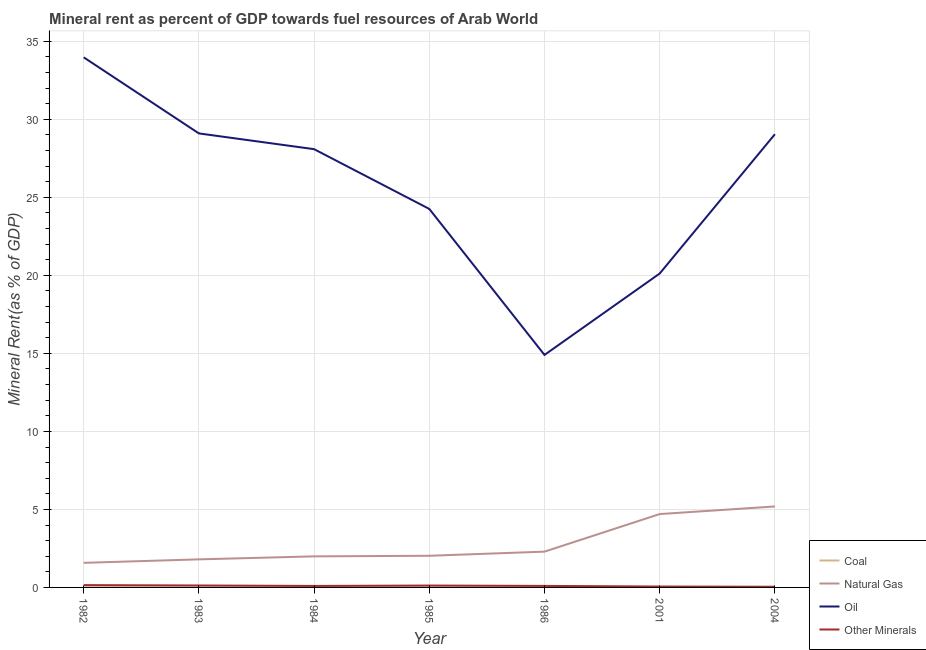How many different coloured lines are there?
Provide a succinct answer. 4. Does the line corresponding to oil rent intersect with the line corresponding to  rent of other minerals?
Provide a short and direct response. No. What is the oil rent in 2004?
Offer a terse response. 29.05. Across all years, what is the maximum  rent of other minerals?
Provide a succinct answer. 0.15. Across all years, what is the minimum natural gas rent?
Provide a short and direct response. 1.58. In which year was the natural gas rent maximum?
Provide a succinct answer. 2004. What is the total  rent of other minerals in the graph?
Provide a short and direct response. 0.69. What is the difference between the coal rent in 1982 and that in 1984?
Offer a very short reply. 0. What is the difference between the  rent of other minerals in 2001 and the natural gas rent in 1983?
Offer a very short reply. -1.74. What is the average oil rent per year?
Provide a succinct answer. 25.64. In the year 2004, what is the difference between the coal rent and oil rent?
Provide a short and direct response. -29.05. What is the ratio of the natural gas rent in 1985 to that in 2001?
Ensure brevity in your answer.  0.43. What is the difference between the highest and the second highest  rent of other minerals?
Your answer should be very brief. 0.02. What is the difference between the highest and the lowest oil rent?
Give a very brief answer. 19.07. Is it the case that in every year, the sum of the coal rent and natural gas rent is greater than the oil rent?
Your response must be concise. No. How many years are there in the graph?
Offer a very short reply. 7. Are the values on the major ticks of Y-axis written in scientific E-notation?
Offer a terse response. No. Does the graph contain any zero values?
Make the answer very short. No. How many legend labels are there?
Keep it short and to the point. 4. What is the title of the graph?
Provide a short and direct response. Mineral rent as percent of GDP towards fuel resources of Arab World. Does "Greece" appear as one of the legend labels in the graph?
Ensure brevity in your answer.  No. What is the label or title of the Y-axis?
Make the answer very short. Mineral Rent(as % of GDP). What is the Mineral Rent(as % of GDP) of Coal in 1982?
Provide a short and direct response. 0. What is the Mineral Rent(as % of GDP) of Natural Gas in 1982?
Your answer should be compact. 1.58. What is the Mineral Rent(as % of GDP) of Oil in 1982?
Make the answer very short. 33.98. What is the Mineral Rent(as % of GDP) of Other Minerals in 1982?
Your answer should be very brief. 0.15. What is the Mineral Rent(as % of GDP) of Coal in 1983?
Offer a terse response. 0. What is the Mineral Rent(as % of GDP) of Natural Gas in 1983?
Offer a very short reply. 1.8. What is the Mineral Rent(as % of GDP) in Oil in 1983?
Your response must be concise. 29.1. What is the Mineral Rent(as % of GDP) of Other Minerals in 1983?
Make the answer very short. 0.12. What is the Mineral Rent(as % of GDP) in Coal in 1984?
Your answer should be compact. 0. What is the Mineral Rent(as % of GDP) of Natural Gas in 1984?
Give a very brief answer. 1.99. What is the Mineral Rent(as % of GDP) in Oil in 1984?
Your answer should be very brief. 28.09. What is the Mineral Rent(as % of GDP) of Other Minerals in 1984?
Give a very brief answer. 0.1. What is the Mineral Rent(as % of GDP) of Coal in 1985?
Ensure brevity in your answer.  0. What is the Mineral Rent(as % of GDP) in Natural Gas in 1985?
Make the answer very short. 2.03. What is the Mineral Rent(as % of GDP) in Oil in 1985?
Provide a succinct answer. 24.26. What is the Mineral Rent(as % of GDP) in Other Minerals in 1985?
Provide a short and direct response. 0.12. What is the Mineral Rent(as % of GDP) of Coal in 1986?
Offer a terse response. 1.4156492772429e-5. What is the Mineral Rent(as % of GDP) in Natural Gas in 1986?
Give a very brief answer. 2.29. What is the Mineral Rent(as % of GDP) in Oil in 1986?
Your response must be concise. 14.9. What is the Mineral Rent(as % of GDP) of Other Minerals in 1986?
Give a very brief answer. 0.1. What is the Mineral Rent(as % of GDP) of Coal in 2001?
Keep it short and to the point. 1.52442917434249e-7. What is the Mineral Rent(as % of GDP) in Natural Gas in 2001?
Your answer should be very brief. 4.7. What is the Mineral Rent(as % of GDP) in Oil in 2001?
Your answer should be compact. 20.12. What is the Mineral Rent(as % of GDP) in Other Minerals in 2001?
Keep it short and to the point. 0.06. What is the Mineral Rent(as % of GDP) of Coal in 2004?
Your answer should be compact. 0. What is the Mineral Rent(as % of GDP) of Natural Gas in 2004?
Your answer should be compact. 5.19. What is the Mineral Rent(as % of GDP) in Oil in 2004?
Offer a very short reply. 29.05. What is the Mineral Rent(as % of GDP) in Other Minerals in 2004?
Keep it short and to the point. 0.04. Across all years, what is the maximum Mineral Rent(as % of GDP) in Coal?
Ensure brevity in your answer.  0. Across all years, what is the maximum Mineral Rent(as % of GDP) of Natural Gas?
Keep it short and to the point. 5.19. Across all years, what is the maximum Mineral Rent(as % of GDP) of Oil?
Your response must be concise. 33.98. Across all years, what is the maximum Mineral Rent(as % of GDP) in Other Minerals?
Keep it short and to the point. 0.15. Across all years, what is the minimum Mineral Rent(as % of GDP) in Coal?
Your answer should be very brief. 1.52442917434249e-7. Across all years, what is the minimum Mineral Rent(as % of GDP) of Natural Gas?
Ensure brevity in your answer.  1.58. Across all years, what is the minimum Mineral Rent(as % of GDP) in Oil?
Your answer should be very brief. 14.9. Across all years, what is the minimum Mineral Rent(as % of GDP) of Other Minerals?
Offer a very short reply. 0.04. What is the total Mineral Rent(as % of GDP) in Coal in the graph?
Offer a very short reply. 0.01. What is the total Mineral Rent(as % of GDP) of Natural Gas in the graph?
Offer a very short reply. 19.58. What is the total Mineral Rent(as % of GDP) of Oil in the graph?
Your answer should be compact. 179.5. What is the total Mineral Rent(as % of GDP) of Other Minerals in the graph?
Keep it short and to the point. 0.69. What is the difference between the Mineral Rent(as % of GDP) in Coal in 1982 and that in 1983?
Ensure brevity in your answer.  0. What is the difference between the Mineral Rent(as % of GDP) in Natural Gas in 1982 and that in 1983?
Provide a short and direct response. -0.22. What is the difference between the Mineral Rent(as % of GDP) in Oil in 1982 and that in 1983?
Offer a terse response. 4.88. What is the difference between the Mineral Rent(as % of GDP) of Other Minerals in 1982 and that in 1983?
Ensure brevity in your answer.  0.02. What is the difference between the Mineral Rent(as % of GDP) of Coal in 1982 and that in 1984?
Provide a succinct answer. 0. What is the difference between the Mineral Rent(as % of GDP) in Natural Gas in 1982 and that in 1984?
Provide a succinct answer. -0.42. What is the difference between the Mineral Rent(as % of GDP) of Oil in 1982 and that in 1984?
Make the answer very short. 5.89. What is the difference between the Mineral Rent(as % of GDP) in Other Minerals in 1982 and that in 1984?
Provide a short and direct response. 0.05. What is the difference between the Mineral Rent(as % of GDP) of Coal in 1982 and that in 1985?
Give a very brief answer. 0. What is the difference between the Mineral Rent(as % of GDP) in Natural Gas in 1982 and that in 1985?
Provide a short and direct response. -0.45. What is the difference between the Mineral Rent(as % of GDP) in Oil in 1982 and that in 1985?
Ensure brevity in your answer.  9.72. What is the difference between the Mineral Rent(as % of GDP) of Other Minerals in 1982 and that in 1985?
Provide a short and direct response. 0.03. What is the difference between the Mineral Rent(as % of GDP) of Coal in 1982 and that in 1986?
Provide a short and direct response. 0. What is the difference between the Mineral Rent(as % of GDP) in Natural Gas in 1982 and that in 1986?
Offer a terse response. -0.72. What is the difference between the Mineral Rent(as % of GDP) of Oil in 1982 and that in 1986?
Provide a succinct answer. 19.07. What is the difference between the Mineral Rent(as % of GDP) of Other Minerals in 1982 and that in 1986?
Your answer should be very brief. 0.05. What is the difference between the Mineral Rent(as % of GDP) of Coal in 1982 and that in 2001?
Keep it short and to the point. 0. What is the difference between the Mineral Rent(as % of GDP) in Natural Gas in 1982 and that in 2001?
Give a very brief answer. -3.13. What is the difference between the Mineral Rent(as % of GDP) in Oil in 1982 and that in 2001?
Keep it short and to the point. 13.86. What is the difference between the Mineral Rent(as % of GDP) in Other Minerals in 1982 and that in 2001?
Provide a succinct answer. 0.09. What is the difference between the Mineral Rent(as % of GDP) in Coal in 1982 and that in 2004?
Make the answer very short. 0. What is the difference between the Mineral Rent(as % of GDP) in Natural Gas in 1982 and that in 2004?
Provide a short and direct response. -3.61. What is the difference between the Mineral Rent(as % of GDP) of Oil in 1982 and that in 2004?
Provide a succinct answer. 4.93. What is the difference between the Mineral Rent(as % of GDP) of Other Minerals in 1982 and that in 2004?
Provide a short and direct response. 0.1. What is the difference between the Mineral Rent(as % of GDP) of Coal in 1983 and that in 1984?
Your answer should be compact. 0. What is the difference between the Mineral Rent(as % of GDP) in Natural Gas in 1983 and that in 1984?
Ensure brevity in your answer.  -0.19. What is the difference between the Mineral Rent(as % of GDP) in Oil in 1983 and that in 1984?
Your answer should be compact. 1.01. What is the difference between the Mineral Rent(as % of GDP) of Other Minerals in 1983 and that in 1984?
Provide a short and direct response. 0.03. What is the difference between the Mineral Rent(as % of GDP) of Natural Gas in 1983 and that in 1985?
Your answer should be very brief. -0.23. What is the difference between the Mineral Rent(as % of GDP) in Oil in 1983 and that in 1985?
Offer a terse response. 4.84. What is the difference between the Mineral Rent(as % of GDP) in Other Minerals in 1983 and that in 1985?
Your answer should be very brief. 0. What is the difference between the Mineral Rent(as % of GDP) in Coal in 1983 and that in 1986?
Make the answer very short. 0. What is the difference between the Mineral Rent(as % of GDP) of Natural Gas in 1983 and that in 1986?
Your answer should be compact. -0.49. What is the difference between the Mineral Rent(as % of GDP) of Oil in 1983 and that in 1986?
Provide a succinct answer. 14.2. What is the difference between the Mineral Rent(as % of GDP) of Other Minerals in 1983 and that in 1986?
Offer a very short reply. 0.03. What is the difference between the Mineral Rent(as % of GDP) of Coal in 1983 and that in 2001?
Provide a succinct answer. 0. What is the difference between the Mineral Rent(as % of GDP) in Natural Gas in 1983 and that in 2001?
Make the answer very short. -2.9. What is the difference between the Mineral Rent(as % of GDP) of Oil in 1983 and that in 2001?
Keep it short and to the point. 8.98. What is the difference between the Mineral Rent(as % of GDP) in Other Minerals in 1983 and that in 2001?
Give a very brief answer. 0.07. What is the difference between the Mineral Rent(as % of GDP) of Coal in 1983 and that in 2004?
Offer a very short reply. 0. What is the difference between the Mineral Rent(as % of GDP) of Natural Gas in 1983 and that in 2004?
Offer a very short reply. -3.39. What is the difference between the Mineral Rent(as % of GDP) in Oil in 1983 and that in 2004?
Offer a very short reply. 0.05. What is the difference between the Mineral Rent(as % of GDP) in Other Minerals in 1983 and that in 2004?
Give a very brief answer. 0.08. What is the difference between the Mineral Rent(as % of GDP) of Coal in 1984 and that in 1985?
Your response must be concise. -0. What is the difference between the Mineral Rent(as % of GDP) of Natural Gas in 1984 and that in 1985?
Offer a terse response. -0.04. What is the difference between the Mineral Rent(as % of GDP) in Oil in 1984 and that in 1985?
Your answer should be very brief. 3.83. What is the difference between the Mineral Rent(as % of GDP) of Other Minerals in 1984 and that in 1985?
Offer a terse response. -0.03. What is the difference between the Mineral Rent(as % of GDP) of Coal in 1984 and that in 1986?
Provide a succinct answer. 0. What is the difference between the Mineral Rent(as % of GDP) in Natural Gas in 1984 and that in 1986?
Offer a very short reply. -0.3. What is the difference between the Mineral Rent(as % of GDP) of Oil in 1984 and that in 1986?
Ensure brevity in your answer.  13.19. What is the difference between the Mineral Rent(as % of GDP) of Other Minerals in 1984 and that in 1986?
Offer a very short reply. -0. What is the difference between the Mineral Rent(as % of GDP) of Coal in 1984 and that in 2001?
Make the answer very short. 0. What is the difference between the Mineral Rent(as % of GDP) of Natural Gas in 1984 and that in 2001?
Ensure brevity in your answer.  -2.71. What is the difference between the Mineral Rent(as % of GDP) of Oil in 1984 and that in 2001?
Offer a very short reply. 7.97. What is the difference between the Mineral Rent(as % of GDP) in Other Minerals in 1984 and that in 2001?
Your answer should be compact. 0.04. What is the difference between the Mineral Rent(as % of GDP) in Coal in 1984 and that in 2004?
Provide a succinct answer. 0. What is the difference between the Mineral Rent(as % of GDP) in Natural Gas in 1984 and that in 2004?
Your response must be concise. -3.2. What is the difference between the Mineral Rent(as % of GDP) of Oil in 1984 and that in 2004?
Provide a short and direct response. -0.96. What is the difference between the Mineral Rent(as % of GDP) in Other Minerals in 1984 and that in 2004?
Ensure brevity in your answer.  0.05. What is the difference between the Mineral Rent(as % of GDP) of Coal in 1985 and that in 1986?
Your response must be concise. 0. What is the difference between the Mineral Rent(as % of GDP) in Natural Gas in 1985 and that in 1986?
Your answer should be very brief. -0.26. What is the difference between the Mineral Rent(as % of GDP) in Oil in 1985 and that in 1986?
Offer a terse response. 9.36. What is the difference between the Mineral Rent(as % of GDP) in Other Minerals in 1985 and that in 1986?
Give a very brief answer. 0.02. What is the difference between the Mineral Rent(as % of GDP) in Coal in 1985 and that in 2001?
Make the answer very short. 0. What is the difference between the Mineral Rent(as % of GDP) of Natural Gas in 1985 and that in 2001?
Your answer should be compact. -2.67. What is the difference between the Mineral Rent(as % of GDP) in Oil in 1985 and that in 2001?
Provide a short and direct response. 4.14. What is the difference between the Mineral Rent(as % of GDP) of Other Minerals in 1985 and that in 2001?
Your answer should be very brief. 0.06. What is the difference between the Mineral Rent(as % of GDP) of Coal in 1985 and that in 2004?
Give a very brief answer. 0. What is the difference between the Mineral Rent(as % of GDP) of Natural Gas in 1985 and that in 2004?
Give a very brief answer. -3.16. What is the difference between the Mineral Rent(as % of GDP) in Oil in 1985 and that in 2004?
Offer a terse response. -4.79. What is the difference between the Mineral Rent(as % of GDP) of Other Minerals in 1985 and that in 2004?
Provide a succinct answer. 0.08. What is the difference between the Mineral Rent(as % of GDP) of Coal in 1986 and that in 2001?
Ensure brevity in your answer.  0. What is the difference between the Mineral Rent(as % of GDP) in Natural Gas in 1986 and that in 2001?
Your response must be concise. -2.41. What is the difference between the Mineral Rent(as % of GDP) of Oil in 1986 and that in 2001?
Offer a very short reply. -5.22. What is the difference between the Mineral Rent(as % of GDP) of Other Minerals in 1986 and that in 2001?
Your answer should be very brief. 0.04. What is the difference between the Mineral Rent(as % of GDP) of Coal in 1986 and that in 2004?
Provide a short and direct response. -0. What is the difference between the Mineral Rent(as % of GDP) of Natural Gas in 1986 and that in 2004?
Offer a terse response. -2.9. What is the difference between the Mineral Rent(as % of GDP) in Oil in 1986 and that in 2004?
Your answer should be compact. -14.15. What is the difference between the Mineral Rent(as % of GDP) in Other Minerals in 1986 and that in 2004?
Your response must be concise. 0.05. What is the difference between the Mineral Rent(as % of GDP) of Coal in 2001 and that in 2004?
Ensure brevity in your answer.  -0. What is the difference between the Mineral Rent(as % of GDP) of Natural Gas in 2001 and that in 2004?
Make the answer very short. -0.49. What is the difference between the Mineral Rent(as % of GDP) of Oil in 2001 and that in 2004?
Provide a short and direct response. -8.93. What is the difference between the Mineral Rent(as % of GDP) in Other Minerals in 2001 and that in 2004?
Provide a short and direct response. 0.01. What is the difference between the Mineral Rent(as % of GDP) in Coal in 1982 and the Mineral Rent(as % of GDP) in Natural Gas in 1983?
Your answer should be compact. -1.8. What is the difference between the Mineral Rent(as % of GDP) of Coal in 1982 and the Mineral Rent(as % of GDP) of Oil in 1983?
Make the answer very short. -29.1. What is the difference between the Mineral Rent(as % of GDP) in Coal in 1982 and the Mineral Rent(as % of GDP) in Other Minerals in 1983?
Make the answer very short. -0.12. What is the difference between the Mineral Rent(as % of GDP) of Natural Gas in 1982 and the Mineral Rent(as % of GDP) of Oil in 1983?
Give a very brief answer. -27.52. What is the difference between the Mineral Rent(as % of GDP) in Natural Gas in 1982 and the Mineral Rent(as % of GDP) in Other Minerals in 1983?
Provide a short and direct response. 1.45. What is the difference between the Mineral Rent(as % of GDP) in Oil in 1982 and the Mineral Rent(as % of GDP) in Other Minerals in 1983?
Provide a short and direct response. 33.85. What is the difference between the Mineral Rent(as % of GDP) of Coal in 1982 and the Mineral Rent(as % of GDP) of Natural Gas in 1984?
Your response must be concise. -1.99. What is the difference between the Mineral Rent(as % of GDP) of Coal in 1982 and the Mineral Rent(as % of GDP) of Oil in 1984?
Your answer should be compact. -28.09. What is the difference between the Mineral Rent(as % of GDP) in Coal in 1982 and the Mineral Rent(as % of GDP) in Other Minerals in 1984?
Make the answer very short. -0.09. What is the difference between the Mineral Rent(as % of GDP) in Natural Gas in 1982 and the Mineral Rent(as % of GDP) in Oil in 1984?
Make the answer very short. -26.51. What is the difference between the Mineral Rent(as % of GDP) in Natural Gas in 1982 and the Mineral Rent(as % of GDP) in Other Minerals in 1984?
Offer a terse response. 1.48. What is the difference between the Mineral Rent(as % of GDP) in Oil in 1982 and the Mineral Rent(as % of GDP) in Other Minerals in 1984?
Make the answer very short. 33.88. What is the difference between the Mineral Rent(as % of GDP) in Coal in 1982 and the Mineral Rent(as % of GDP) in Natural Gas in 1985?
Provide a succinct answer. -2.03. What is the difference between the Mineral Rent(as % of GDP) in Coal in 1982 and the Mineral Rent(as % of GDP) in Oil in 1985?
Your response must be concise. -24.26. What is the difference between the Mineral Rent(as % of GDP) in Coal in 1982 and the Mineral Rent(as % of GDP) in Other Minerals in 1985?
Keep it short and to the point. -0.12. What is the difference between the Mineral Rent(as % of GDP) of Natural Gas in 1982 and the Mineral Rent(as % of GDP) of Oil in 1985?
Keep it short and to the point. -22.68. What is the difference between the Mineral Rent(as % of GDP) of Natural Gas in 1982 and the Mineral Rent(as % of GDP) of Other Minerals in 1985?
Give a very brief answer. 1.45. What is the difference between the Mineral Rent(as % of GDP) in Oil in 1982 and the Mineral Rent(as % of GDP) in Other Minerals in 1985?
Give a very brief answer. 33.86. What is the difference between the Mineral Rent(as % of GDP) in Coal in 1982 and the Mineral Rent(as % of GDP) in Natural Gas in 1986?
Ensure brevity in your answer.  -2.29. What is the difference between the Mineral Rent(as % of GDP) in Coal in 1982 and the Mineral Rent(as % of GDP) in Oil in 1986?
Ensure brevity in your answer.  -14.9. What is the difference between the Mineral Rent(as % of GDP) of Coal in 1982 and the Mineral Rent(as % of GDP) of Other Minerals in 1986?
Give a very brief answer. -0.09. What is the difference between the Mineral Rent(as % of GDP) of Natural Gas in 1982 and the Mineral Rent(as % of GDP) of Oil in 1986?
Offer a terse response. -13.33. What is the difference between the Mineral Rent(as % of GDP) in Natural Gas in 1982 and the Mineral Rent(as % of GDP) in Other Minerals in 1986?
Give a very brief answer. 1.48. What is the difference between the Mineral Rent(as % of GDP) in Oil in 1982 and the Mineral Rent(as % of GDP) in Other Minerals in 1986?
Your answer should be compact. 33.88. What is the difference between the Mineral Rent(as % of GDP) of Coal in 1982 and the Mineral Rent(as % of GDP) of Natural Gas in 2001?
Provide a short and direct response. -4.7. What is the difference between the Mineral Rent(as % of GDP) in Coal in 1982 and the Mineral Rent(as % of GDP) in Oil in 2001?
Keep it short and to the point. -20.12. What is the difference between the Mineral Rent(as % of GDP) in Coal in 1982 and the Mineral Rent(as % of GDP) in Other Minerals in 2001?
Provide a succinct answer. -0.05. What is the difference between the Mineral Rent(as % of GDP) of Natural Gas in 1982 and the Mineral Rent(as % of GDP) of Oil in 2001?
Give a very brief answer. -18.54. What is the difference between the Mineral Rent(as % of GDP) in Natural Gas in 1982 and the Mineral Rent(as % of GDP) in Other Minerals in 2001?
Offer a very short reply. 1.52. What is the difference between the Mineral Rent(as % of GDP) of Oil in 1982 and the Mineral Rent(as % of GDP) of Other Minerals in 2001?
Your answer should be very brief. 33.92. What is the difference between the Mineral Rent(as % of GDP) of Coal in 1982 and the Mineral Rent(as % of GDP) of Natural Gas in 2004?
Your response must be concise. -5.19. What is the difference between the Mineral Rent(as % of GDP) in Coal in 1982 and the Mineral Rent(as % of GDP) in Oil in 2004?
Provide a succinct answer. -29.04. What is the difference between the Mineral Rent(as % of GDP) of Coal in 1982 and the Mineral Rent(as % of GDP) of Other Minerals in 2004?
Keep it short and to the point. -0.04. What is the difference between the Mineral Rent(as % of GDP) of Natural Gas in 1982 and the Mineral Rent(as % of GDP) of Oil in 2004?
Your answer should be compact. -27.47. What is the difference between the Mineral Rent(as % of GDP) in Natural Gas in 1982 and the Mineral Rent(as % of GDP) in Other Minerals in 2004?
Offer a terse response. 1.53. What is the difference between the Mineral Rent(as % of GDP) in Oil in 1982 and the Mineral Rent(as % of GDP) in Other Minerals in 2004?
Your response must be concise. 33.93. What is the difference between the Mineral Rent(as % of GDP) of Coal in 1983 and the Mineral Rent(as % of GDP) of Natural Gas in 1984?
Provide a short and direct response. -1.99. What is the difference between the Mineral Rent(as % of GDP) of Coal in 1983 and the Mineral Rent(as % of GDP) of Oil in 1984?
Offer a very short reply. -28.09. What is the difference between the Mineral Rent(as % of GDP) in Coal in 1983 and the Mineral Rent(as % of GDP) in Other Minerals in 1984?
Give a very brief answer. -0.09. What is the difference between the Mineral Rent(as % of GDP) of Natural Gas in 1983 and the Mineral Rent(as % of GDP) of Oil in 1984?
Offer a very short reply. -26.29. What is the difference between the Mineral Rent(as % of GDP) of Natural Gas in 1983 and the Mineral Rent(as % of GDP) of Other Minerals in 1984?
Your response must be concise. 1.7. What is the difference between the Mineral Rent(as % of GDP) in Oil in 1983 and the Mineral Rent(as % of GDP) in Other Minerals in 1984?
Offer a terse response. 29. What is the difference between the Mineral Rent(as % of GDP) of Coal in 1983 and the Mineral Rent(as % of GDP) of Natural Gas in 1985?
Your answer should be compact. -2.03. What is the difference between the Mineral Rent(as % of GDP) in Coal in 1983 and the Mineral Rent(as % of GDP) in Oil in 1985?
Keep it short and to the point. -24.26. What is the difference between the Mineral Rent(as % of GDP) in Coal in 1983 and the Mineral Rent(as % of GDP) in Other Minerals in 1985?
Your answer should be compact. -0.12. What is the difference between the Mineral Rent(as % of GDP) of Natural Gas in 1983 and the Mineral Rent(as % of GDP) of Oil in 1985?
Your response must be concise. -22.46. What is the difference between the Mineral Rent(as % of GDP) of Natural Gas in 1983 and the Mineral Rent(as % of GDP) of Other Minerals in 1985?
Ensure brevity in your answer.  1.68. What is the difference between the Mineral Rent(as % of GDP) of Oil in 1983 and the Mineral Rent(as % of GDP) of Other Minerals in 1985?
Your response must be concise. 28.98. What is the difference between the Mineral Rent(as % of GDP) of Coal in 1983 and the Mineral Rent(as % of GDP) of Natural Gas in 1986?
Offer a terse response. -2.29. What is the difference between the Mineral Rent(as % of GDP) of Coal in 1983 and the Mineral Rent(as % of GDP) of Oil in 1986?
Your answer should be very brief. -14.9. What is the difference between the Mineral Rent(as % of GDP) of Coal in 1983 and the Mineral Rent(as % of GDP) of Other Minerals in 1986?
Make the answer very short. -0.1. What is the difference between the Mineral Rent(as % of GDP) of Natural Gas in 1983 and the Mineral Rent(as % of GDP) of Oil in 1986?
Offer a very short reply. -13.1. What is the difference between the Mineral Rent(as % of GDP) in Natural Gas in 1983 and the Mineral Rent(as % of GDP) in Other Minerals in 1986?
Keep it short and to the point. 1.7. What is the difference between the Mineral Rent(as % of GDP) of Oil in 1983 and the Mineral Rent(as % of GDP) of Other Minerals in 1986?
Your answer should be very brief. 29. What is the difference between the Mineral Rent(as % of GDP) of Coal in 1983 and the Mineral Rent(as % of GDP) of Natural Gas in 2001?
Your answer should be compact. -4.7. What is the difference between the Mineral Rent(as % of GDP) in Coal in 1983 and the Mineral Rent(as % of GDP) in Oil in 2001?
Provide a short and direct response. -20.12. What is the difference between the Mineral Rent(as % of GDP) in Coal in 1983 and the Mineral Rent(as % of GDP) in Other Minerals in 2001?
Offer a terse response. -0.06. What is the difference between the Mineral Rent(as % of GDP) of Natural Gas in 1983 and the Mineral Rent(as % of GDP) of Oil in 2001?
Give a very brief answer. -18.32. What is the difference between the Mineral Rent(as % of GDP) of Natural Gas in 1983 and the Mineral Rent(as % of GDP) of Other Minerals in 2001?
Offer a terse response. 1.74. What is the difference between the Mineral Rent(as % of GDP) of Oil in 1983 and the Mineral Rent(as % of GDP) of Other Minerals in 2001?
Your answer should be very brief. 29.04. What is the difference between the Mineral Rent(as % of GDP) of Coal in 1983 and the Mineral Rent(as % of GDP) of Natural Gas in 2004?
Give a very brief answer. -5.19. What is the difference between the Mineral Rent(as % of GDP) of Coal in 1983 and the Mineral Rent(as % of GDP) of Oil in 2004?
Ensure brevity in your answer.  -29.05. What is the difference between the Mineral Rent(as % of GDP) of Coal in 1983 and the Mineral Rent(as % of GDP) of Other Minerals in 2004?
Offer a very short reply. -0.04. What is the difference between the Mineral Rent(as % of GDP) of Natural Gas in 1983 and the Mineral Rent(as % of GDP) of Oil in 2004?
Offer a terse response. -27.25. What is the difference between the Mineral Rent(as % of GDP) of Natural Gas in 1983 and the Mineral Rent(as % of GDP) of Other Minerals in 2004?
Provide a short and direct response. 1.76. What is the difference between the Mineral Rent(as % of GDP) of Oil in 1983 and the Mineral Rent(as % of GDP) of Other Minerals in 2004?
Make the answer very short. 29.06. What is the difference between the Mineral Rent(as % of GDP) in Coal in 1984 and the Mineral Rent(as % of GDP) in Natural Gas in 1985?
Keep it short and to the point. -2.03. What is the difference between the Mineral Rent(as % of GDP) of Coal in 1984 and the Mineral Rent(as % of GDP) of Oil in 1985?
Offer a terse response. -24.26. What is the difference between the Mineral Rent(as % of GDP) of Coal in 1984 and the Mineral Rent(as % of GDP) of Other Minerals in 1985?
Your answer should be compact. -0.12. What is the difference between the Mineral Rent(as % of GDP) in Natural Gas in 1984 and the Mineral Rent(as % of GDP) in Oil in 1985?
Provide a succinct answer. -22.27. What is the difference between the Mineral Rent(as % of GDP) in Natural Gas in 1984 and the Mineral Rent(as % of GDP) in Other Minerals in 1985?
Keep it short and to the point. 1.87. What is the difference between the Mineral Rent(as % of GDP) of Oil in 1984 and the Mineral Rent(as % of GDP) of Other Minerals in 1985?
Your answer should be compact. 27.97. What is the difference between the Mineral Rent(as % of GDP) of Coal in 1984 and the Mineral Rent(as % of GDP) of Natural Gas in 1986?
Provide a succinct answer. -2.29. What is the difference between the Mineral Rent(as % of GDP) of Coal in 1984 and the Mineral Rent(as % of GDP) of Oil in 1986?
Ensure brevity in your answer.  -14.9. What is the difference between the Mineral Rent(as % of GDP) of Coal in 1984 and the Mineral Rent(as % of GDP) of Other Minerals in 1986?
Keep it short and to the point. -0.1. What is the difference between the Mineral Rent(as % of GDP) in Natural Gas in 1984 and the Mineral Rent(as % of GDP) in Oil in 1986?
Your response must be concise. -12.91. What is the difference between the Mineral Rent(as % of GDP) in Natural Gas in 1984 and the Mineral Rent(as % of GDP) in Other Minerals in 1986?
Your answer should be very brief. 1.89. What is the difference between the Mineral Rent(as % of GDP) in Oil in 1984 and the Mineral Rent(as % of GDP) in Other Minerals in 1986?
Your response must be concise. 27.99. What is the difference between the Mineral Rent(as % of GDP) of Coal in 1984 and the Mineral Rent(as % of GDP) of Natural Gas in 2001?
Provide a succinct answer. -4.7. What is the difference between the Mineral Rent(as % of GDP) in Coal in 1984 and the Mineral Rent(as % of GDP) in Oil in 2001?
Your answer should be very brief. -20.12. What is the difference between the Mineral Rent(as % of GDP) in Coal in 1984 and the Mineral Rent(as % of GDP) in Other Minerals in 2001?
Offer a terse response. -0.06. What is the difference between the Mineral Rent(as % of GDP) of Natural Gas in 1984 and the Mineral Rent(as % of GDP) of Oil in 2001?
Offer a very short reply. -18.13. What is the difference between the Mineral Rent(as % of GDP) in Natural Gas in 1984 and the Mineral Rent(as % of GDP) in Other Minerals in 2001?
Give a very brief answer. 1.93. What is the difference between the Mineral Rent(as % of GDP) in Oil in 1984 and the Mineral Rent(as % of GDP) in Other Minerals in 2001?
Offer a very short reply. 28.03. What is the difference between the Mineral Rent(as % of GDP) in Coal in 1984 and the Mineral Rent(as % of GDP) in Natural Gas in 2004?
Your answer should be compact. -5.19. What is the difference between the Mineral Rent(as % of GDP) in Coal in 1984 and the Mineral Rent(as % of GDP) in Oil in 2004?
Keep it short and to the point. -29.05. What is the difference between the Mineral Rent(as % of GDP) of Coal in 1984 and the Mineral Rent(as % of GDP) of Other Minerals in 2004?
Offer a terse response. -0.04. What is the difference between the Mineral Rent(as % of GDP) of Natural Gas in 1984 and the Mineral Rent(as % of GDP) of Oil in 2004?
Give a very brief answer. -27.06. What is the difference between the Mineral Rent(as % of GDP) of Natural Gas in 1984 and the Mineral Rent(as % of GDP) of Other Minerals in 2004?
Make the answer very short. 1.95. What is the difference between the Mineral Rent(as % of GDP) of Oil in 1984 and the Mineral Rent(as % of GDP) of Other Minerals in 2004?
Ensure brevity in your answer.  28.05. What is the difference between the Mineral Rent(as % of GDP) in Coal in 1985 and the Mineral Rent(as % of GDP) in Natural Gas in 1986?
Keep it short and to the point. -2.29. What is the difference between the Mineral Rent(as % of GDP) in Coal in 1985 and the Mineral Rent(as % of GDP) in Oil in 1986?
Offer a very short reply. -14.9. What is the difference between the Mineral Rent(as % of GDP) in Coal in 1985 and the Mineral Rent(as % of GDP) in Other Minerals in 1986?
Your response must be concise. -0.1. What is the difference between the Mineral Rent(as % of GDP) in Natural Gas in 1985 and the Mineral Rent(as % of GDP) in Oil in 1986?
Your answer should be compact. -12.87. What is the difference between the Mineral Rent(as % of GDP) of Natural Gas in 1985 and the Mineral Rent(as % of GDP) of Other Minerals in 1986?
Ensure brevity in your answer.  1.93. What is the difference between the Mineral Rent(as % of GDP) of Oil in 1985 and the Mineral Rent(as % of GDP) of Other Minerals in 1986?
Your answer should be compact. 24.16. What is the difference between the Mineral Rent(as % of GDP) of Coal in 1985 and the Mineral Rent(as % of GDP) of Natural Gas in 2001?
Offer a terse response. -4.7. What is the difference between the Mineral Rent(as % of GDP) of Coal in 1985 and the Mineral Rent(as % of GDP) of Oil in 2001?
Your answer should be compact. -20.12. What is the difference between the Mineral Rent(as % of GDP) in Coal in 1985 and the Mineral Rent(as % of GDP) in Other Minerals in 2001?
Your answer should be very brief. -0.06. What is the difference between the Mineral Rent(as % of GDP) of Natural Gas in 1985 and the Mineral Rent(as % of GDP) of Oil in 2001?
Your answer should be very brief. -18.09. What is the difference between the Mineral Rent(as % of GDP) of Natural Gas in 1985 and the Mineral Rent(as % of GDP) of Other Minerals in 2001?
Ensure brevity in your answer.  1.97. What is the difference between the Mineral Rent(as % of GDP) of Oil in 1985 and the Mineral Rent(as % of GDP) of Other Minerals in 2001?
Keep it short and to the point. 24.2. What is the difference between the Mineral Rent(as % of GDP) of Coal in 1985 and the Mineral Rent(as % of GDP) of Natural Gas in 2004?
Provide a short and direct response. -5.19. What is the difference between the Mineral Rent(as % of GDP) in Coal in 1985 and the Mineral Rent(as % of GDP) in Oil in 2004?
Ensure brevity in your answer.  -29.05. What is the difference between the Mineral Rent(as % of GDP) in Coal in 1985 and the Mineral Rent(as % of GDP) in Other Minerals in 2004?
Ensure brevity in your answer.  -0.04. What is the difference between the Mineral Rent(as % of GDP) in Natural Gas in 1985 and the Mineral Rent(as % of GDP) in Oil in 2004?
Your answer should be compact. -27.02. What is the difference between the Mineral Rent(as % of GDP) of Natural Gas in 1985 and the Mineral Rent(as % of GDP) of Other Minerals in 2004?
Your answer should be compact. 1.99. What is the difference between the Mineral Rent(as % of GDP) in Oil in 1985 and the Mineral Rent(as % of GDP) in Other Minerals in 2004?
Your response must be concise. 24.22. What is the difference between the Mineral Rent(as % of GDP) in Coal in 1986 and the Mineral Rent(as % of GDP) in Natural Gas in 2001?
Your response must be concise. -4.7. What is the difference between the Mineral Rent(as % of GDP) of Coal in 1986 and the Mineral Rent(as % of GDP) of Oil in 2001?
Provide a succinct answer. -20.12. What is the difference between the Mineral Rent(as % of GDP) of Coal in 1986 and the Mineral Rent(as % of GDP) of Other Minerals in 2001?
Your response must be concise. -0.06. What is the difference between the Mineral Rent(as % of GDP) in Natural Gas in 1986 and the Mineral Rent(as % of GDP) in Oil in 2001?
Offer a terse response. -17.83. What is the difference between the Mineral Rent(as % of GDP) in Natural Gas in 1986 and the Mineral Rent(as % of GDP) in Other Minerals in 2001?
Your answer should be very brief. 2.24. What is the difference between the Mineral Rent(as % of GDP) in Oil in 1986 and the Mineral Rent(as % of GDP) in Other Minerals in 2001?
Your answer should be compact. 14.85. What is the difference between the Mineral Rent(as % of GDP) of Coal in 1986 and the Mineral Rent(as % of GDP) of Natural Gas in 2004?
Provide a short and direct response. -5.19. What is the difference between the Mineral Rent(as % of GDP) in Coal in 1986 and the Mineral Rent(as % of GDP) in Oil in 2004?
Offer a very short reply. -29.05. What is the difference between the Mineral Rent(as % of GDP) of Coal in 1986 and the Mineral Rent(as % of GDP) of Other Minerals in 2004?
Give a very brief answer. -0.04. What is the difference between the Mineral Rent(as % of GDP) in Natural Gas in 1986 and the Mineral Rent(as % of GDP) in Oil in 2004?
Keep it short and to the point. -26.75. What is the difference between the Mineral Rent(as % of GDP) in Natural Gas in 1986 and the Mineral Rent(as % of GDP) in Other Minerals in 2004?
Provide a succinct answer. 2.25. What is the difference between the Mineral Rent(as % of GDP) in Oil in 1986 and the Mineral Rent(as % of GDP) in Other Minerals in 2004?
Make the answer very short. 14.86. What is the difference between the Mineral Rent(as % of GDP) of Coal in 2001 and the Mineral Rent(as % of GDP) of Natural Gas in 2004?
Your answer should be very brief. -5.19. What is the difference between the Mineral Rent(as % of GDP) in Coal in 2001 and the Mineral Rent(as % of GDP) in Oil in 2004?
Give a very brief answer. -29.05. What is the difference between the Mineral Rent(as % of GDP) of Coal in 2001 and the Mineral Rent(as % of GDP) of Other Minerals in 2004?
Your answer should be compact. -0.04. What is the difference between the Mineral Rent(as % of GDP) of Natural Gas in 2001 and the Mineral Rent(as % of GDP) of Oil in 2004?
Your response must be concise. -24.35. What is the difference between the Mineral Rent(as % of GDP) in Natural Gas in 2001 and the Mineral Rent(as % of GDP) in Other Minerals in 2004?
Your answer should be very brief. 4.66. What is the difference between the Mineral Rent(as % of GDP) in Oil in 2001 and the Mineral Rent(as % of GDP) in Other Minerals in 2004?
Make the answer very short. 20.08. What is the average Mineral Rent(as % of GDP) in Coal per year?
Keep it short and to the point. 0. What is the average Mineral Rent(as % of GDP) of Natural Gas per year?
Offer a very short reply. 2.8. What is the average Mineral Rent(as % of GDP) of Oil per year?
Your response must be concise. 25.64. What is the average Mineral Rent(as % of GDP) of Other Minerals per year?
Keep it short and to the point. 0.1. In the year 1982, what is the difference between the Mineral Rent(as % of GDP) of Coal and Mineral Rent(as % of GDP) of Natural Gas?
Ensure brevity in your answer.  -1.57. In the year 1982, what is the difference between the Mineral Rent(as % of GDP) in Coal and Mineral Rent(as % of GDP) in Oil?
Keep it short and to the point. -33.97. In the year 1982, what is the difference between the Mineral Rent(as % of GDP) of Coal and Mineral Rent(as % of GDP) of Other Minerals?
Make the answer very short. -0.14. In the year 1982, what is the difference between the Mineral Rent(as % of GDP) of Natural Gas and Mineral Rent(as % of GDP) of Oil?
Provide a short and direct response. -32.4. In the year 1982, what is the difference between the Mineral Rent(as % of GDP) in Natural Gas and Mineral Rent(as % of GDP) in Other Minerals?
Provide a short and direct response. 1.43. In the year 1982, what is the difference between the Mineral Rent(as % of GDP) of Oil and Mineral Rent(as % of GDP) of Other Minerals?
Your answer should be very brief. 33.83. In the year 1983, what is the difference between the Mineral Rent(as % of GDP) of Coal and Mineral Rent(as % of GDP) of Natural Gas?
Make the answer very short. -1.8. In the year 1983, what is the difference between the Mineral Rent(as % of GDP) of Coal and Mineral Rent(as % of GDP) of Oil?
Your response must be concise. -29.1. In the year 1983, what is the difference between the Mineral Rent(as % of GDP) in Coal and Mineral Rent(as % of GDP) in Other Minerals?
Your answer should be compact. -0.12. In the year 1983, what is the difference between the Mineral Rent(as % of GDP) of Natural Gas and Mineral Rent(as % of GDP) of Oil?
Offer a terse response. -27.3. In the year 1983, what is the difference between the Mineral Rent(as % of GDP) in Natural Gas and Mineral Rent(as % of GDP) in Other Minerals?
Offer a very short reply. 1.68. In the year 1983, what is the difference between the Mineral Rent(as % of GDP) of Oil and Mineral Rent(as % of GDP) of Other Minerals?
Your response must be concise. 28.98. In the year 1984, what is the difference between the Mineral Rent(as % of GDP) of Coal and Mineral Rent(as % of GDP) of Natural Gas?
Provide a short and direct response. -1.99. In the year 1984, what is the difference between the Mineral Rent(as % of GDP) of Coal and Mineral Rent(as % of GDP) of Oil?
Provide a succinct answer. -28.09. In the year 1984, what is the difference between the Mineral Rent(as % of GDP) in Coal and Mineral Rent(as % of GDP) in Other Minerals?
Ensure brevity in your answer.  -0.09. In the year 1984, what is the difference between the Mineral Rent(as % of GDP) in Natural Gas and Mineral Rent(as % of GDP) in Oil?
Ensure brevity in your answer.  -26.1. In the year 1984, what is the difference between the Mineral Rent(as % of GDP) of Natural Gas and Mineral Rent(as % of GDP) of Other Minerals?
Your answer should be compact. 1.9. In the year 1984, what is the difference between the Mineral Rent(as % of GDP) in Oil and Mineral Rent(as % of GDP) in Other Minerals?
Offer a terse response. 27.99. In the year 1985, what is the difference between the Mineral Rent(as % of GDP) in Coal and Mineral Rent(as % of GDP) in Natural Gas?
Your response must be concise. -2.03. In the year 1985, what is the difference between the Mineral Rent(as % of GDP) of Coal and Mineral Rent(as % of GDP) of Oil?
Provide a succinct answer. -24.26. In the year 1985, what is the difference between the Mineral Rent(as % of GDP) in Coal and Mineral Rent(as % of GDP) in Other Minerals?
Keep it short and to the point. -0.12. In the year 1985, what is the difference between the Mineral Rent(as % of GDP) of Natural Gas and Mineral Rent(as % of GDP) of Oil?
Provide a succinct answer. -22.23. In the year 1985, what is the difference between the Mineral Rent(as % of GDP) of Natural Gas and Mineral Rent(as % of GDP) of Other Minerals?
Give a very brief answer. 1.91. In the year 1985, what is the difference between the Mineral Rent(as % of GDP) of Oil and Mineral Rent(as % of GDP) of Other Minerals?
Your response must be concise. 24.14. In the year 1986, what is the difference between the Mineral Rent(as % of GDP) of Coal and Mineral Rent(as % of GDP) of Natural Gas?
Give a very brief answer. -2.29. In the year 1986, what is the difference between the Mineral Rent(as % of GDP) of Coal and Mineral Rent(as % of GDP) of Oil?
Your answer should be compact. -14.9. In the year 1986, what is the difference between the Mineral Rent(as % of GDP) in Coal and Mineral Rent(as % of GDP) in Other Minerals?
Offer a terse response. -0.1. In the year 1986, what is the difference between the Mineral Rent(as % of GDP) in Natural Gas and Mineral Rent(as % of GDP) in Oil?
Make the answer very short. -12.61. In the year 1986, what is the difference between the Mineral Rent(as % of GDP) of Natural Gas and Mineral Rent(as % of GDP) of Other Minerals?
Give a very brief answer. 2.2. In the year 1986, what is the difference between the Mineral Rent(as % of GDP) in Oil and Mineral Rent(as % of GDP) in Other Minerals?
Offer a terse response. 14.8. In the year 2001, what is the difference between the Mineral Rent(as % of GDP) in Coal and Mineral Rent(as % of GDP) in Natural Gas?
Provide a short and direct response. -4.7. In the year 2001, what is the difference between the Mineral Rent(as % of GDP) in Coal and Mineral Rent(as % of GDP) in Oil?
Offer a very short reply. -20.12. In the year 2001, what is the difference between the Mineral Rent(as % of GDP) of Coal and Mineral Rent(as % of GDP) of Other Minerals?
Your answer should be very brief. -0.06. In the year 2001, what is the difference between the Mineral Rent(as % of GDP) in Natural Gas and Mineral Rent(as % of GDP) in Oil?
Give a very brief answer. -15.42. In the year 2001, what is the difference between the Mineral Rent(as % of GDP) in Natural Gas and Mineral Rent(as % of GDP) in Other Minerals?
Keep it short and to the point. 4.65. In the year 2001, what is the difference between the Mineral Rent(as % of GDP) of Oil and Mineral Rent(as % of GDP) of Other Minerals?
Ensure brevity in your answer.  20.06. In the year 2004, what is the difference between the Mineral Rent(as % of GDP) of Coal and Mineral Rent(as % of GDP) of Natural Gas?
Ensure brevity in your answer.  -5.19. In the year 2004, what is the difference between the Mineral Rent(as % of GDP) of Coal and Mineral Rent(as % of GDP) of Oil?
Offer a very short reply. -29.05. In the year 2004, what is the difference between the Mineral Rent(as % of GDP) of Coal and Mineral Rent(as % of GDP) of Other Minerals?
Your response must be concise. -0.04. In the year 2004, what is the difference between the Mineral Rent(as % of GDP) of Natural Gas and Mineral Rent(as % of GDP) of Oil?
Your response must be concise. -23.86. In the year 2004, what is the difference between the Mineral Rent(as % of GDP) of Natural Gas and Mineral Rent(as % of GDP) of Other Minerals?
Offer a terse response. 5.15. In the year 2004, what is the difference between the Mineral Rent(as % of GDP) in Oil and Mineral Rent(as % of GDP) in Other Minerals?
Ensure brevity in your answer.  29.01. What is the ratio of the Mineral Rent(as % of GDP) in Coal in 1982 to that in 1983?
Ensure brevity in your answer.  2.39. What is the ratio of the Mineral Rent(as % of GDP) of Natural Gas in 1982 to that in 1983?
Provide a short and direct response. 0.88. What is the ratio of the Mineral Rent(as % of GDP) of Oil in 1982 to that in 1983?
Your response must be concise. 1.17. What is the ratio of the Mineral Rent(as % of GDP) of Other Minerals in 1982 to that in 1983?
Give a very brief answer. 1.19. What is the ratio of the Mineral Rent(as % of GDP) of Coal in 1982 to that in 1984?
Your answer should be compact. 4.32. What is the ratio of the Mineral Rent(as % of GDP) in Natural Gas in 1982 to that in 1984?
Your response must be concise. 0.79. What is the ratio of the Mineral Rent(as % of GDP) of Oil in 1982 to that in 1984?
Your answer should be compact. 1.21. What is the ratio of the Mineral Rent(as % of GDP) of Other Minerals in 1982 to that in 1984?
Provide a succinct answer. 1.56. What is the ratio of the Mineral Rent(as % of GDP) in Coal in 1982 to that in 1985?
Keep it short and to the point. 2.95. What is the ratio of the Mineral Rent(as % of GDP) in Natural Gas in 1982 to that in 1985?
Keep it short and to the point. 0.78. What is the ratio of the Mineral Rent(as % of GDP) of Oil in 1982 to that in 1985?
Make the answer very short. 1.4. What is the ratio of the Mineral Rent(as % of GDP) in Other Minerals in 1982 to that in 1985?
Make the answer very short. 1.23. What is the ratio of the Mineral Rent(as % of GDP) in Coal in 1982 to that in 1986?
Your answer should be compact. 276.32. What is the ratio of the Mineral Rent(as % of GDP) in Natural Gas in 1982 to that in 1986?
Your answer should be compact. 0.69. What is the ratio of the Mineral Rent(as % of GDP) in Oil in 1982 to that in 1986?
Make the answer very short. 2.28. What is the ratio of the Mineral Rent(as % of GDP) of Other Minerals in 1982 to that in 1986?
Give a very brief answer. 1.53. What is the ratio of the Mineral Rent(as % of GDP) in Coal in 1982 to that in 2001?
Offer a terse response. 2.57e+04. What is the ratio of the Mineral Rent(as % of GDP) of Natural Gas in 1982 to that in 2001?
Offer a terse response. 0.34. What is the ratio of the Mineral Rent(as % of GDP) of Oil in 1982 to that in 2001?
Provide a succinct answer. 1.69. What is the ratio of the Mineral Rent(as % of GDP) of Other Minerals in 1982 to that in 2001?
Offer a very short reply. 2.61. What is the ratio of the Mineral Rent(as % of GDP) of Coal in 1982 to that in 2004?
Your answer should be very brief. 36.34. What is the ratio of the Mineral Rent(as % of GDP) in Natural Gas in 1982 to that in 2004?
Your response must be concise. 0.3. What is the ratio of the Mineral Rent(as % of GDP) in Oil in 1982 to that in 2004?
Provide a short and direct response. 1.17. What is the ratio of the Mineral Rent(as % of GDP) in Other Minerals in 1982 to that in 2004?
Your response must be concise. 3.4. What is the ratio of the Mineral Rent(as % of GDP) of Coal in 1983 to that in 1984?
Provide a short and direct response. 1.81. What is the ratio of the Mineral Rent(as % of GDP) in Natural Gas in 1983 to that in 1984?
Provide a short and direct response. 0.9. What is the ratio of the Mineral Rent(as % of GDP) of Oil in 1983 to that in 1984?
Provide a succinct answer. 1.04. What is the ratio of the Mineral Rent(as % of GDP) in Other Minerals in 1983 to that in 1984?
Provide a succinct answer. 1.31. What is the ratio of the Mineral Rent(as % of GDP) in Coal in 1983 to that in 1985?
Make the answer very short. 1.23. What is the ratio of the Mineral Rent(as % of GDP) of Natural Gas in 1983 to that in 1985?
Your response must be concise. 0.89. What is the ratio of the Mineral Rent(as % of GDP) of Oil in 1983 to that in 1985?
Offer a very short reply. 1.2. What is the ratio of the Mineral Rent(as % of GDP) of Other Minerals in 1983 to that in 1985?
Offer a very short reply. 1.03. What is the ratio of the Mineral Rent(as % of GDP) of Coal in 1983 to that in 1986?
Make the answer very short. 115.75. What is the ratio of the Mineral Rent(as % of GDP) of Natural Gas in 1983 to that in 1986?
Ensure brevity in your answer.  0.78. What is the ratio of the Mineral Rent(as % of GDP) of Oil in 1983 to that in 1986?
Give a very brief answer. 1.95. What is the ratio of the Mineral Rent(as % of GDP) in Other Minerals in 1983 to that in 1986?
Make the answer very short. 1.28. What is the ratio of the Mineral Rent(as % of GDP) of Coal in 1983 to that in 2001?
Offer a very short reply. 1.07e+04. What is the ratio of the Mineral Rent(as % of GDP) in Natural Gas in 1983 to that in 2001?
Give a very brief answer. 0.38. What is the ratio of the Mineral Rent(as % of GDP) in Oil in 1983 to that in 2001?
Give a very brief answer. 1.45. What is the ratio of the Mineral Rent(as % of GDP) in Other Minerals in 1983 to that in 2001?
Your answer should be compact. 2.18. What is the ratio of the Mineral Rent(as % of GDP) of Coal in 1983 to that in 2004?
Your answer should be compact. 15.22. What is the ratio of the Mineral Rent(as % of GDP) in Natural Gas in 1983 to that in 2004?
Your response must be concise. 0.35. What is the ratio of the Mineral Rent(as % of GDP) of Oil in 1983 to that in 2004?
Provide a succinct answer. 1. What is the ratio of the Mineral Rent(as % of GDP) in Other Minerals in 1983 to that in 2004?
Make the answer very short. 2.84. What is the ratio of the Mineral Rent(as % of GDP) of Coal in 1984 to that in 1985?
Offer a very short reply. 0.68. What is the ratio of the Mineral Rent(as % of GDP) in Natural Gas in 1984 to that in 1985?
Keep it short and to the point. 0.98. What is the ratio of the Mineral Rent(as % of GDP) of Oil in 1984 to that in 1985?
Ensure brevity in your answer.  1.16. What is the ratio of the Mineral Rent(as % of GDP) in Other Minerals in 1984 to that in 1985?
Provide a succinct answer. 0.79. What is the ratio of the Mineral Rent(as % of GDP) of Coal in 1984 to that in 1986?
Your response must be concise. 63.93. What is the ratio of the Mineral Rent(as % of GDP) in Natural Gas in 1984 to that in 1986?
Provide a succinct answer. 0.87. What is the ratio of the Mineral Rent(as % of GDP) of Oil in 1984 to that in 1986?
Provide a short and direct response. 1.88. What is the ratio of the Mineral Rent(as % of GDP) in Other Minerals in 1984 to that in 1986?
Ensure brevity in your answer.  0.98. What is the ratio of the Mineral Rent(as % of GDP) in Coal in 1984 to that in 2001?
Ensure brevity in your answer.  5936.36. What is the ratio of the Mineral Rent(as % of GDP) of Natural Gas in 1984 to that in 2001?
Your response must be concise. 0.42. What is the ratio of the Mineral Rent(as % of GDP) in Oil in 1984 to that in 2001?
Give a very brief answer. 1.4. What is the ratio of the Mineral Rent(as % of GDP) in Other Minerals in 1984 to that in 2001?
Your answer should be compact. 1.67. What is the ratio of the Mineral Rent(as % of GDP) of Coal in 1984 to that in 2004?
Your answer should be very brief. 8.41. What is the ratio of the Mineral Rent(as % of GDP) in Natural Gas in 1984 to that in 2004?
Your response must be concise. 0.38. What is the ratio of the Mineral Rent(as % of GDP) of Oil in 1984 to that in 2004?
Ensure brevity in your answer.  0.97. What is the ratio of the Mineral Rent(as % of GDP) of Other Minerals in 1984 to that in 2004?
Keep it short and to the point. 2.18. What is the ratio of the Mineral Rent(as % of GDP) of Coal in 1985 to that in 1986?
Your answer should be very brief. 93.79. What is the ratio of the Mineral Rent(as % of GDP) of Natural Gas in 1985 to that in 1986?
Provide a succinct answer. 0.88. What is the ratio of the Mineral Rent(as % of GDP) of Oil in 1985 to that in 1986?
Keep it short and to the point. 1.63. What is the ratio of the Mineral Rent(as % of GDP) in Other Minerals in 1985 to that in 1986?
Offer a terse response. 1.24. What is the ratio of the Mineral Rent(as % of GDP) in Coal in 1985 to that in 2001?
Ensure brevity in your answer.  8710.14. What is the ratio of the Mineral Rent(as % of GDP) of Natural Gas in 1985 to that in 2001?
Offer a very short reply. 0.43. What is the ratio of the Mineral Rent(as % of GDP) of Oil in 1985 to that in 2001?
Offer a very short reply. 1.21. What is the ratio of the Mineral Rent(as % of GDP) in Other Minerals in 1985 to that in 2001?
Provide a short and direct response. 2.12. What is the ratio of the Mineral Rent(as % of GDP) in Coal in 1985 to that in 2004?
Offer a very short reply. 12.33. What is the ratio of the Mineral Rent(as % of GDP) in Natural Gas in 1985 to that in 2004?
Keep it short and to the point. 0.39. What is the ratio of the Mineral Rent(as % of GDP) in Oil in 1985 to that in 2004?
Your response must be concise. 0.84. What is the ratio of the Mineral Rent(as % of GDP) in Other Minerals in 1985 to that in 2004?
Your answer should be very brief. 2.76. What is the ratio of the Mineral Rent(as % of GDP) of Coal in 1986 to that in 2001?
Give a very brief answer. 92.86. What is the ratio of the Mineral Rent(as % of GDP) of Natural Gas in 1986 to that in 2001?
Give a very brief answer. 0.49. What is the ratio of the Mineral Rent(as % of GDP) in Oil in 1986 to that in 2001?
Provide a succinct answer. 0.74. What is the ratio of the Mineral Rent(as % of GDP) in Other Minerals in 1986 to that in 2001?
Your response must be concise. 1.71. What is the ratio of the Mineral Rent(as % of GDP) of Coal in 1986 to that in 2004?
Your response must be concise. 0.13. What is the ratio of the Mineral Rent(as % of GDP) in Natural Gas in 1986 to that in 2004?
Your answer should be compact. 0.44. What is the ratio of the Mineral Rent(as % of GDP) of Oil in 1986 to that in 2004?
Provide a succinct answer. 0.51. What is the ratio of the Mineral Rent(as % of GDP) of Other Minerals in 1986 to that in 2004?
Your answer should be compact. 2.22. What is the ratio of the Mineral Rent(as % of GDP) of Coal in 2001 to that in 2004?
Ensure brevity in your answer.  0. What is the ratio of the Mineral Rent(as % of GDP) of Natural Gas in 2001 to that in 2004?
Your response must be concise. 0.91. What is the ratio of the Mineral Rent(as % of GDP) of Oil in 2001 to that in 2004?
Your answer should be compact. 0.69. What is the ratio of the Mineral Rent(as % of GDP) in Other Minerals in 2001 to that in 2004?
Your response must be concise. 1.3. What is the difference between the highest and the second highest Mineral Rent(as % of GDP) in Coal?
Your response must be concise. 0. What is the difference between the highest and the second highest Mineral Rent(as % of GDP) of Natural Gas?
Give a very brief answer. 0.49. What is the difference between the highest and the second highest Mineral Rent(as % of GDP) in Oil?
Provide a short and direct response. 4.88. What is the difference between the highest and the second highest Mineral Rent(as % of GDP) of Other Minerals?
Provide a short and direct response. 0.02. What is the difference between the highest and the lowest Mineral Rent(as % of GDP) in Coal?
Offer a terse response. 0. What is the difference between the highest and the lowest Mineral Rent(as % of GDP) in Natural Gas?
Your answer should be very brief. 3.61. What is the difference between the highest and the lowest Mineral Rent(as % of GDP) of Oil?
Offer a very short reply. 19.07. What is the difference between the highest and the lowest Mineral Rent(as % of GDP) in Other Minerals?
Give a very brief answer. 0.1. 